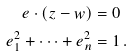Convert formula to latex. <formula><loc_0><loc_0><loc_500><loc_500>e \cdot ( z - w ) & = 0 \\ e _ { 1 } ^ { 2 } + \dots + e _ { n } ^ { 2 } & = 1 \, .</formula> 